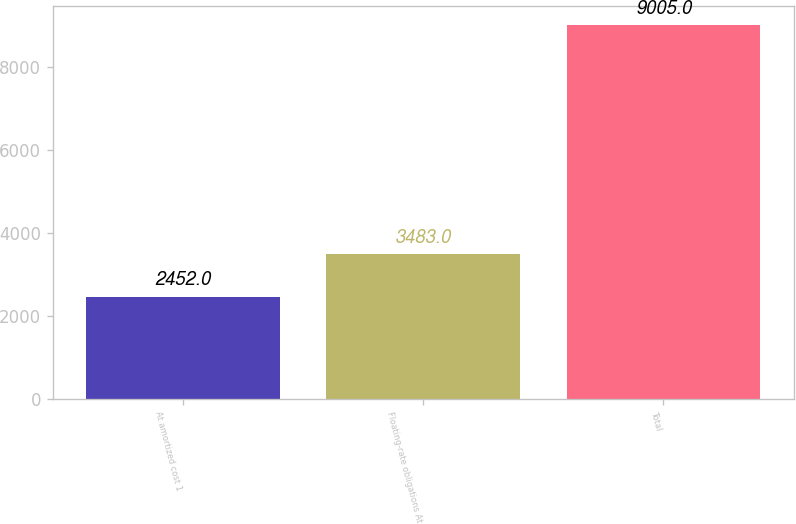Convert chart to OTSL. <chart><loc_0><loc_0><loc_500><loc_500><bar_chart><fcel>At amortized cost 1<fcel>Floating-rate obligations At<fcel>Total<nl><fcel>2452<fcel>3483<fcel>9005<nl></chart> 